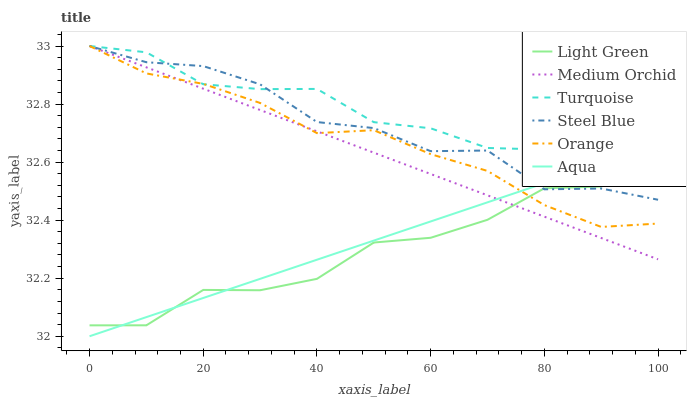Does Light Green have the minimum area under the curve?
Answer yes or no. Yes. Does Turquoise have the maximum area under the curve?
Answer yes or no. Yes. Does Medium Orchid have the minimum area under the curve?
Answer yes or no. No. Does Medium Orchid have the maximum area under the curve?
Answer yes or no. No. Is Medium Orchid the smoothest?
Answer yes or no. Yes. Is Turquoise the roughest?
Answer yes or no. Yes. Is Steel Blue the smoothest?
Answer yes or no. No. Is Steel Blue the roughest?
Answer yes or no. No. Does Aqua have the lowest value?
Answer yes or no. Yes. Does Medium Orchid have the lowest value?
Answer yes or no. No. Does Orange have the highest value?
Answer yes or no. Yes. Does Aqua have the highest value?
Answer yes or no. No. Does Steel Blue intersect Medium Orchid?
Answer yes or no. Yes. Is Steel Blue less than Medium Orchid?
Answer yes or no. No. Is Steel Blue greater than Medium Orchid?
Answer yes or no. No. 